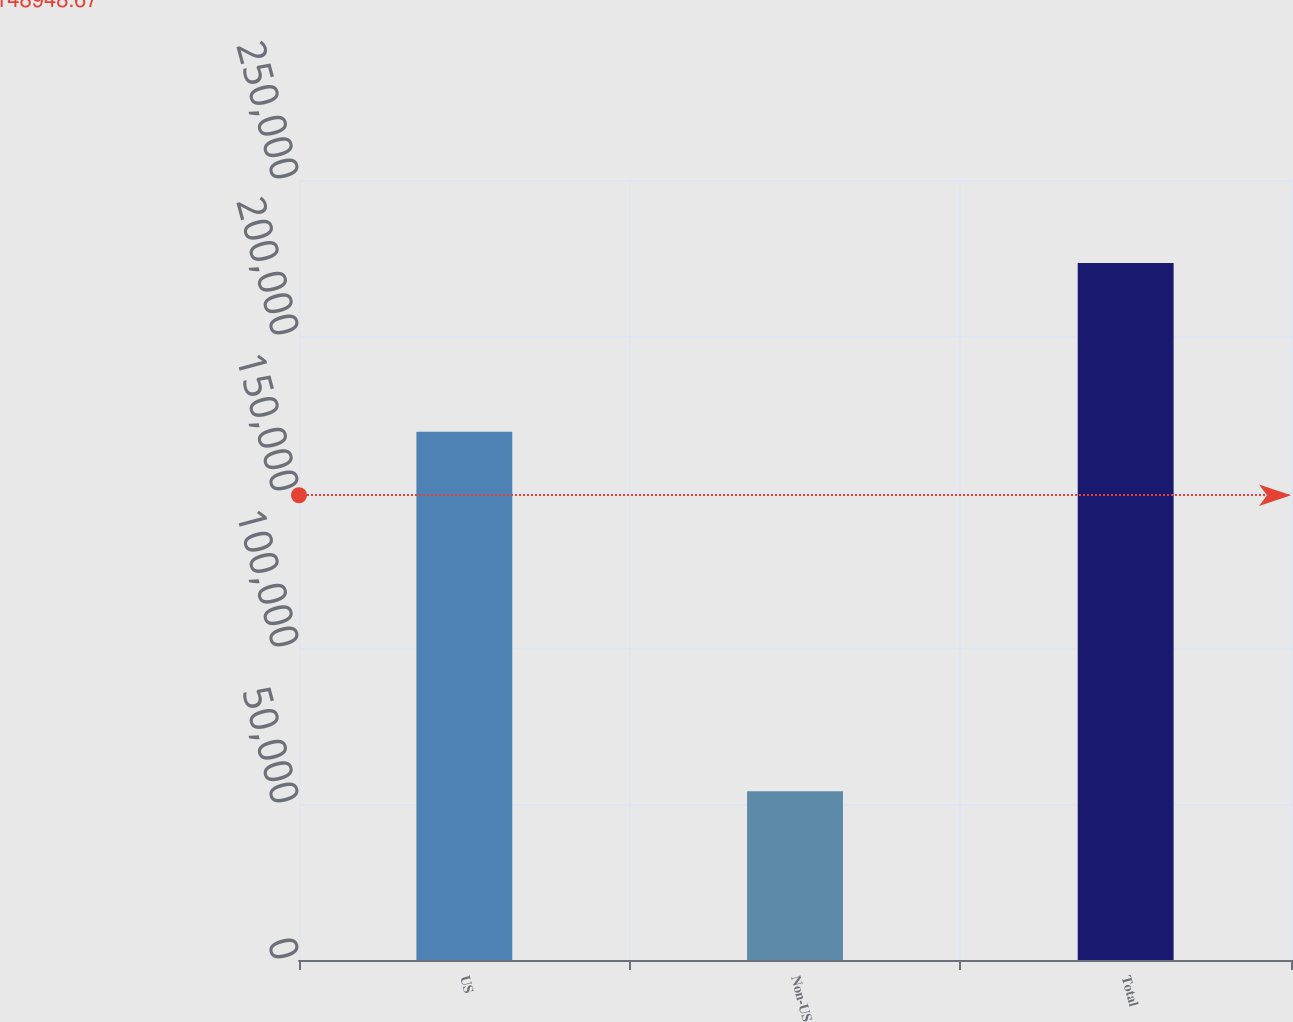Convert chart to OTSL. <chart><loc_0><loc_0><loc_500><loc_500><bar_chart><fcel>US<fcel>Non-US<fcel>Total<nl><fcel>169333<fcel>54090<fcel>223423<nl></chart> 